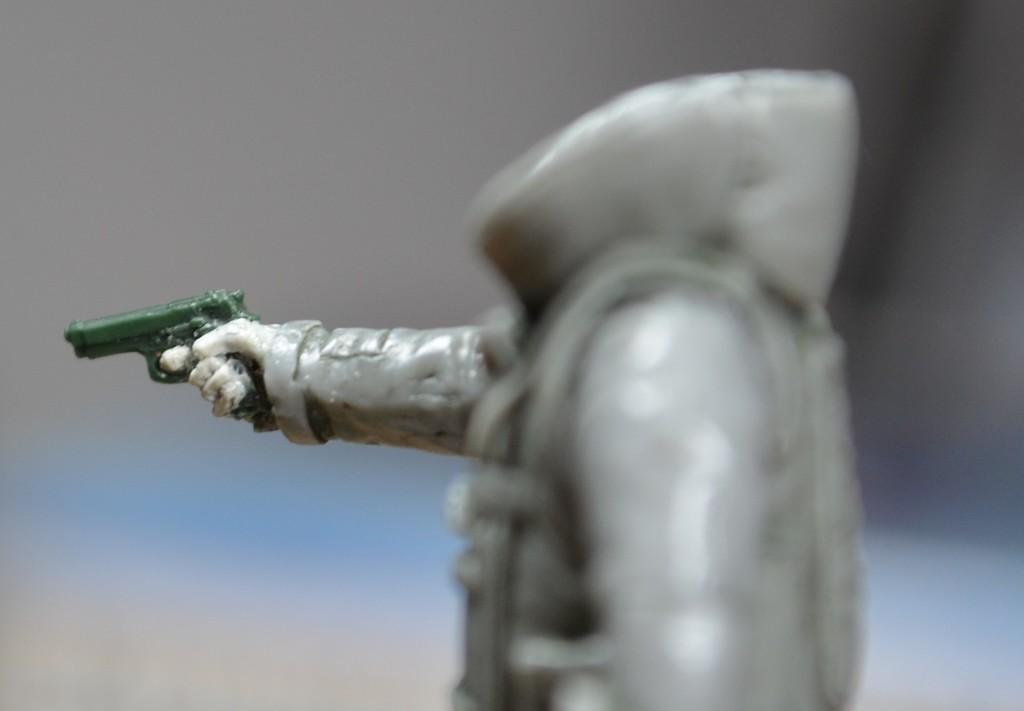How would you summarize this image in a sentence or two? In this picture I can see the toy who is holding a green gun. In the background I can see the blur image. 